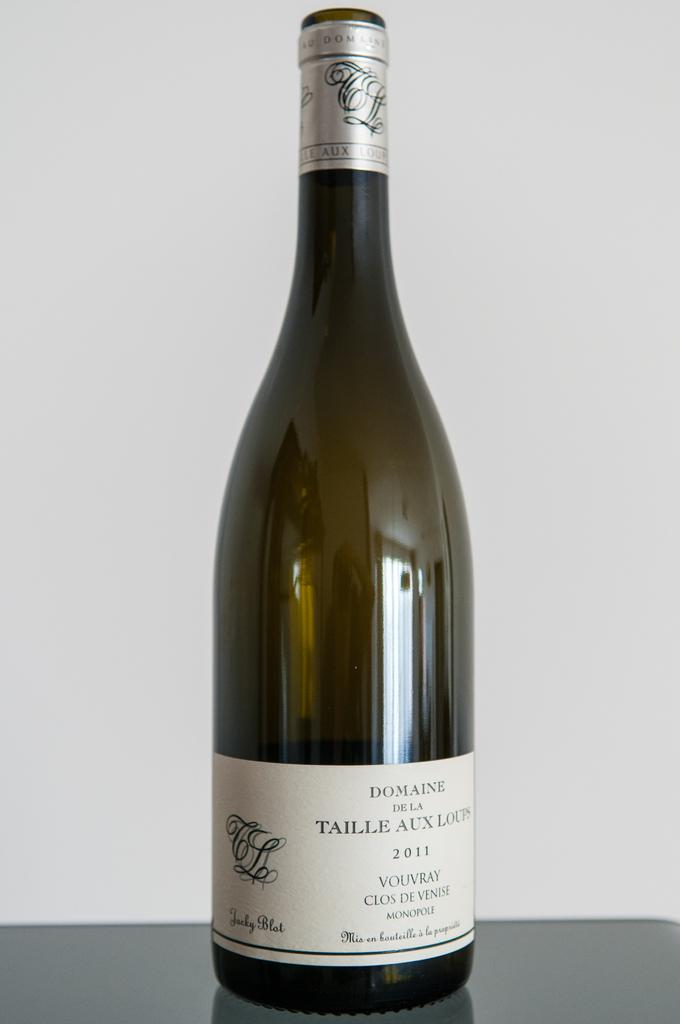What object can be seen in the image? There is a bottle in the image. What colors are present on the bottle? The bottle has a white color sticker and a silver color sticker pasted on it. Where is the bottle located in the image? The bottle is placed on a table. What is the color of the background in the image? The background of the image is white in color. What type of steel is used to make the example treatment visible in the image? There is no steel, example, or treatment present in the image. The image only features a bottle with stickers on a white background. 